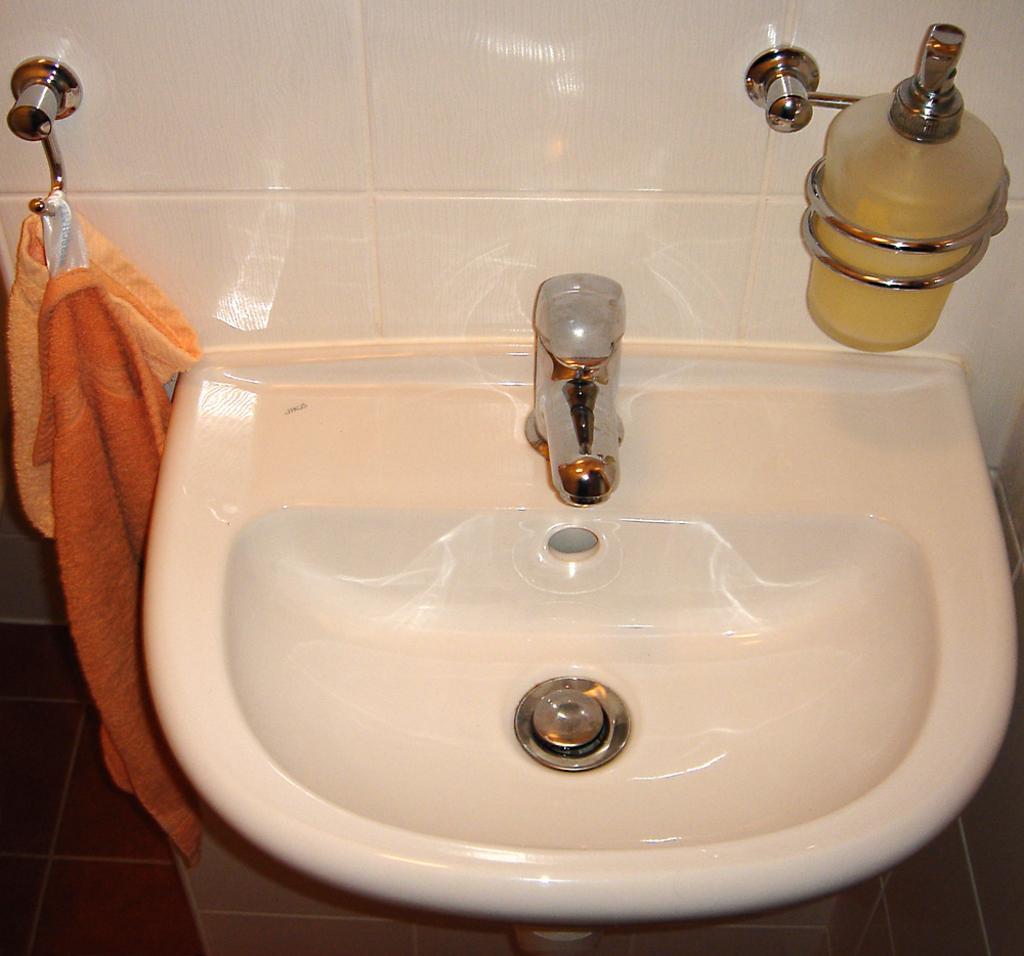Can you describe this image briefly? There is a sink. Under the sink there is a floor which is covered with tiles. Beside the sink there is a cloth hanged to the hanger. A tap is located on the sink. Hand wash is fixed to the wall and the wall is covered with tiles. 